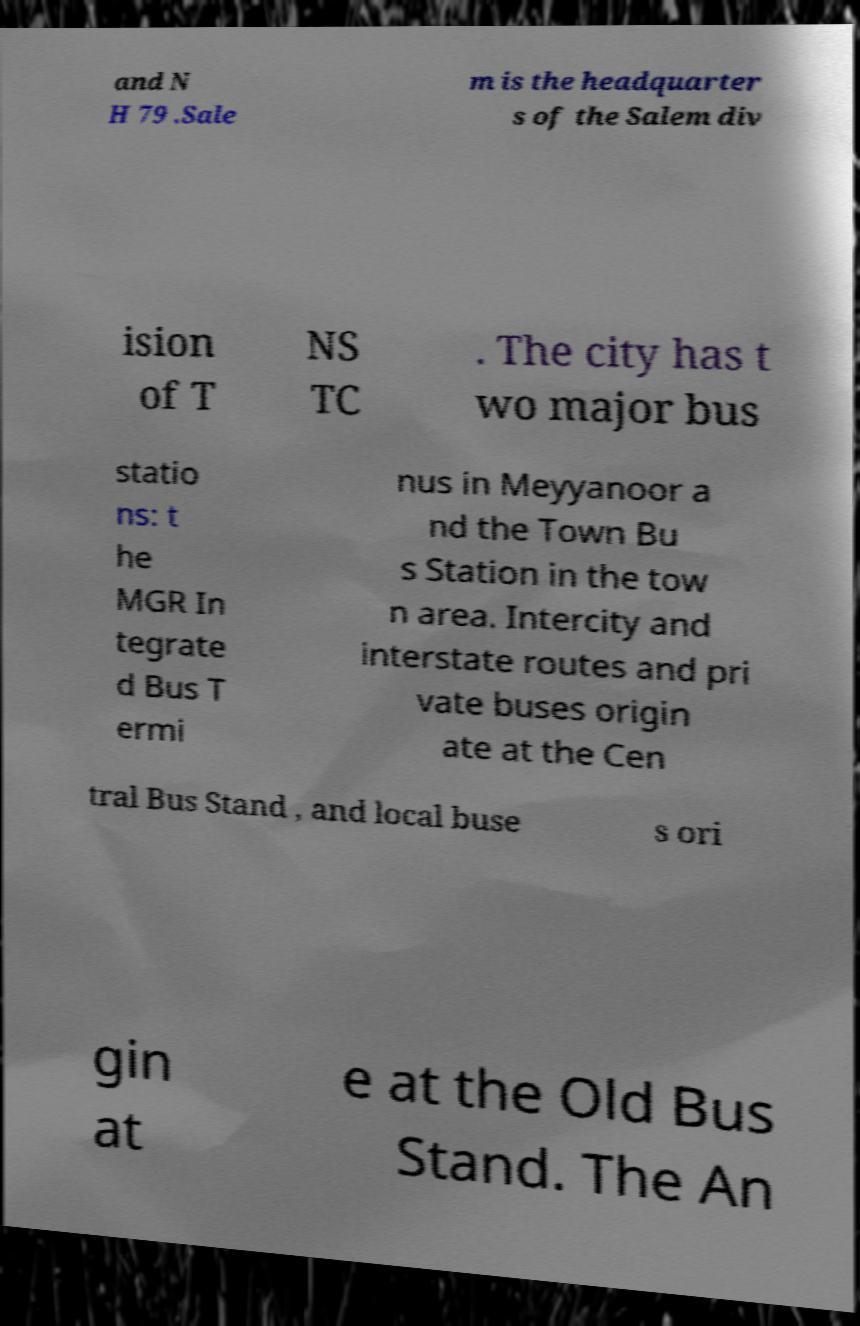Could you assist in decoding the text presented in this image and type it out clearly? and N H 79 .Sale m is the headquarter s of the Salem div ision of T NS TC . The city has t wo major bus statio ns: t he MGR In tegrate d Bus T ermi nus in Meyyanoor a nd the Town Bu s Station in the tow n area. Intercity and interstate routes and pri vate buses origin ate at the Cen tral Bus Stand , and local buse s ori gin at e at the Old Bus Stand. The An 